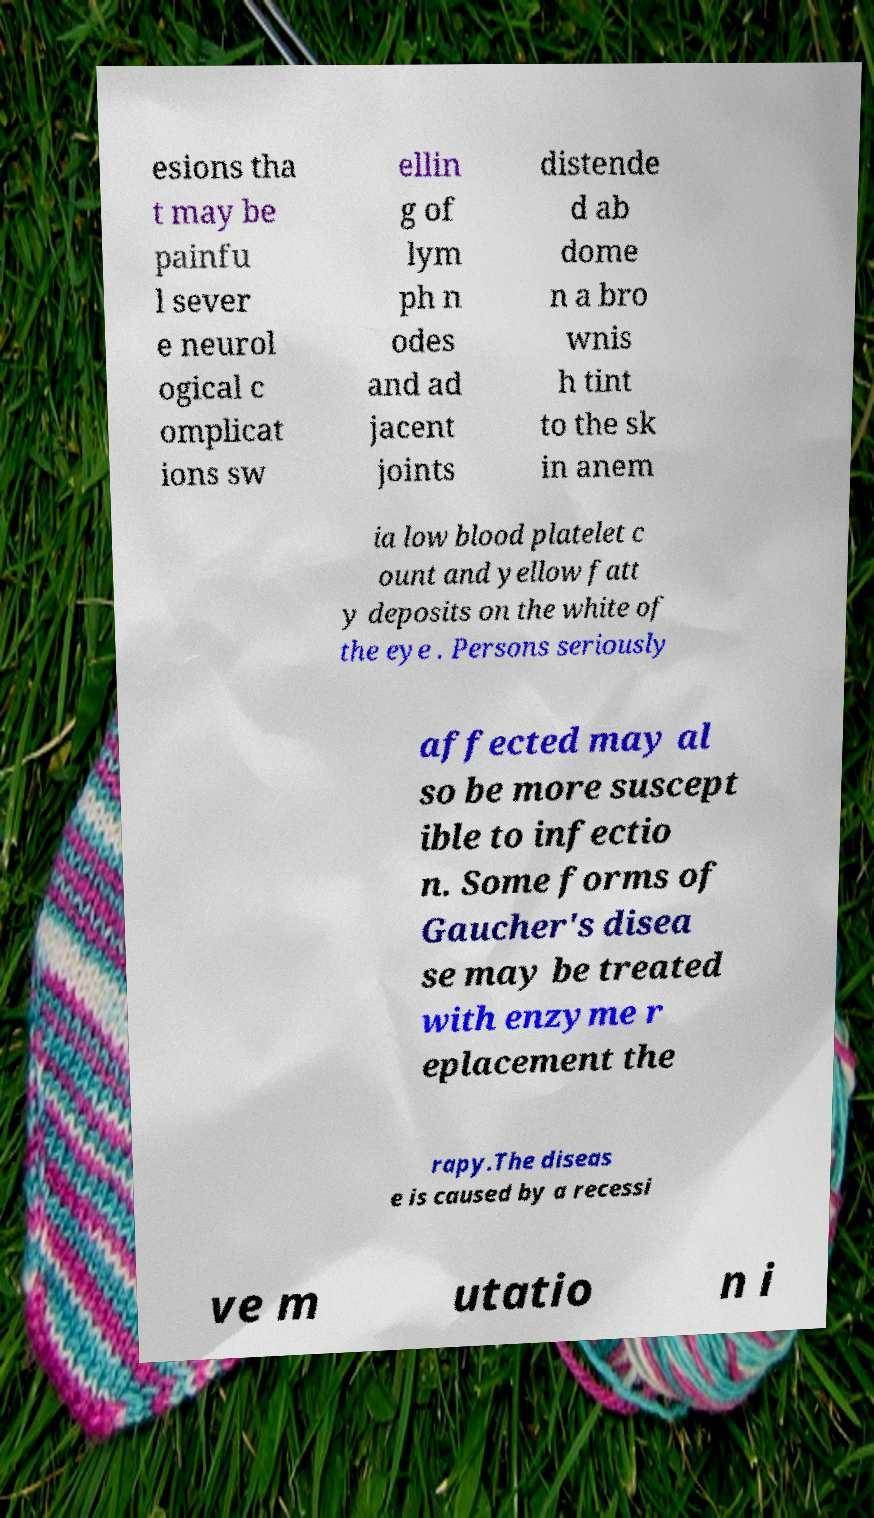Can you read and provide the text displayed in the image?This photo seems to have some interesting text. Can you extract and type it out for me? esions tha t may be painfu l sever e neurol ogical c omplicat ions sw ellin g of lym ph n odes and ad jacent joints distende d ab dome n a bro wnis h tint to the sk in anem ia low blood platelet c ount and yellow fatt y deposits on the white of the eye . Persons seriously affected may al so be more suscept ible to infectio n. Some forms of Gaucher's disea se may be treated with enzyme r eplacement the rapy.The diseas e is caused by a recessi ve m utatio n i 